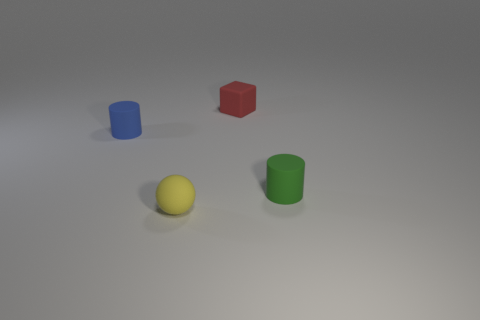Add 4 blue cylinders. How many objects exist? 8 Subtract all cubes. How many objects are left? 3 Subtract 1 cylinders. How many cylinders are left? 1 Subtract all green objects. Subtract all small cylinders. How many objects are left? 1 Add 2 red blocks. How many red blocks are left? 3 Add 2 large purple cubes. How many large purple cubes exist? 2 Subtract all green cylinders. How many cylinders are left? 1 Subtract 1 blue cylinders. How many objects are left? 3 Subtract all gray cylinders. Subtract all yellow balls. How many cylinders are left? 2 Subtract all red cubes. How many green cylinders are left? 1 